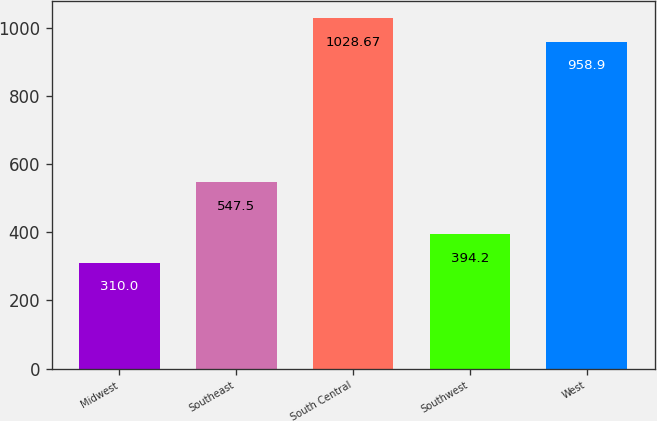Convert chart to OTSL. <chart><loc_0><loc_0><loc_500><loc_500><bar_chart><fcel>Midwest<fcel>Southeast<fcel>South Central<fcel>Southwest<fcel>West<nl><fcel>310<fcel>547.5<fcel>1028.67<fcel>394.2<fcel>958.9<nl></chart> 